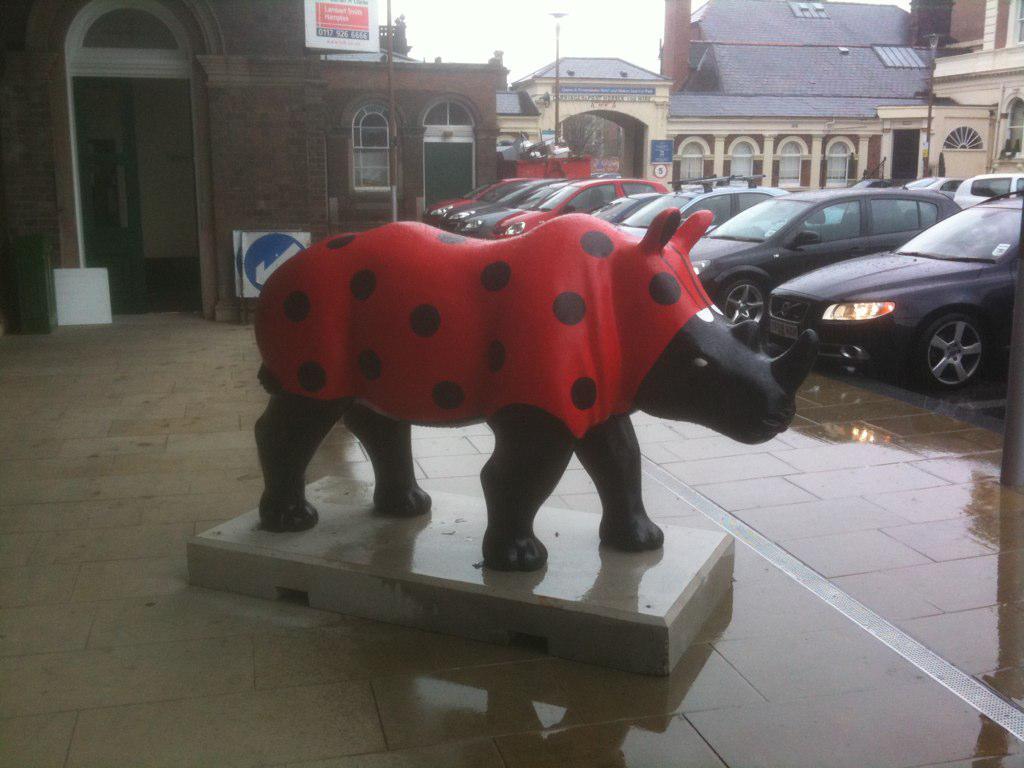Could you give a brief overview of what you see in this image? In the middle of the image we can see statue of a bull, in the background we can find few cars, buildings, poles and sign boards. 